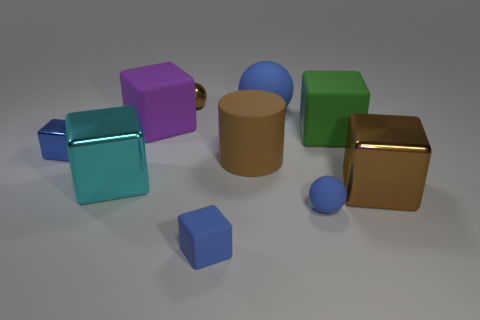Subtract all tiny blue rubber balls. How many balls are left? 2 Subtract all brown balls. How many balls are left? 2 Subtract all cylinders. How many objects are left? 9 Subtract all brown balls. How many blue blocks are left? 2 Add 7 brown shiny cubes. How many brown shiny cubes are left? 8 Add 6 tiny blue blocks. How many tiny blue blocks exist? 8 Subtract 1 green blocks. How many objects are left? 9 Subtract 1 cylinders. How many cylinders are left? 0 Subtract all gray balls. Subtract all blue cylinders. How many balls are left? 3 Subtract all small gray shiny objects. Subtract all blue cubes. How many objects are left? 8 